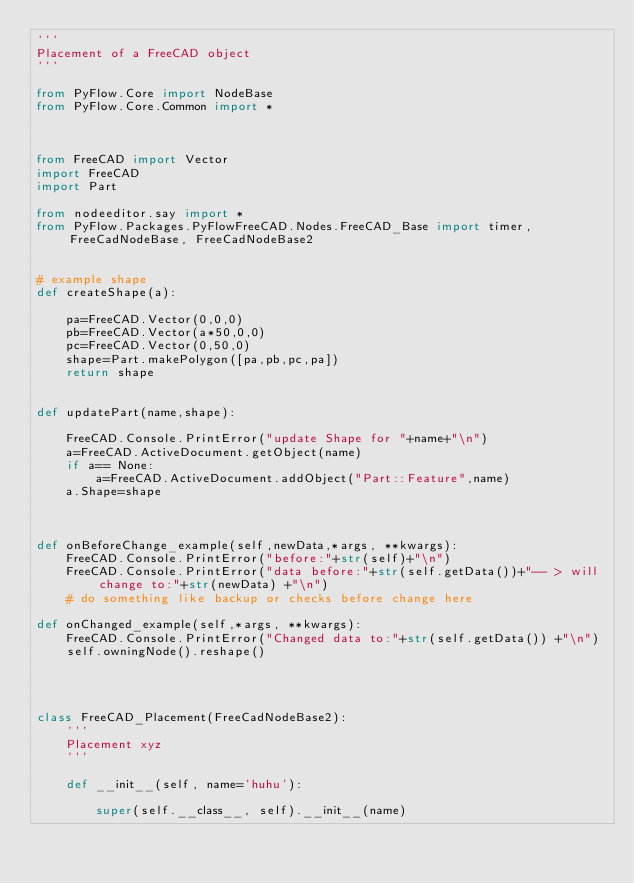<code> <loc_0><loc_0><loc_500><loc_500><_Python_>'''
Placement of a FreeCAD object
'''

from PyFlow.Core import NodeBase
from PyFlow.Core.Common import *



from FreeCAD import Vector
import FreeCAD
import Part

from nodeeditor.say import *
from PyFlow.Packages.PyFlowFreeCAD.Nodes.FreeCAD_Base import timer, FreeCadNodeBase, FreeCadNodeBase2


# example shape
def createShape(a):

    pa=FreeCAD.Vector(0,0,0)
    pb=FreeCAD.Vector(a*50,0,0)
    pc=FreeCAD.Vector(0,50,0)
    shape=Part.makePolygon([pa,pb,pc,pa])
    return shape


def updatePart(name,shape):

    FreeCAD.Console.PrintError("update Shape for "+name+"\n")
    a=FreeCAD.ActiveDocument.getObject(name)
    if a== None:
        a=FreeCAD.ActiveDocument.addObject("Part::Feature",name)
    a.Shape=shape



def onBeforeChange_example(self,newData,*args, **kwargs):
    FreeCAD.Console.PrintError("before:"+str(self)+"\n")
    FreeCAD.Console.PrintError("data before:"+str(self.getData())+"-- > will change to:"+str(newData) +"\n")
    # do something like backup or checks before change here

def onChanged_example(self,*args, **kwargs):
    FreeCAD.Console.PrintError("Changed data to:"+str(self.getData()) +"\n")
    self.owningNode().reshape()




class FreeCAD_Placement(FreeCadNodeBase2):
    '''
    Placement xyz
    '''

    def __init__(self, name='huhu'):

        super(self.__class__, self).__init__(name)</code> 